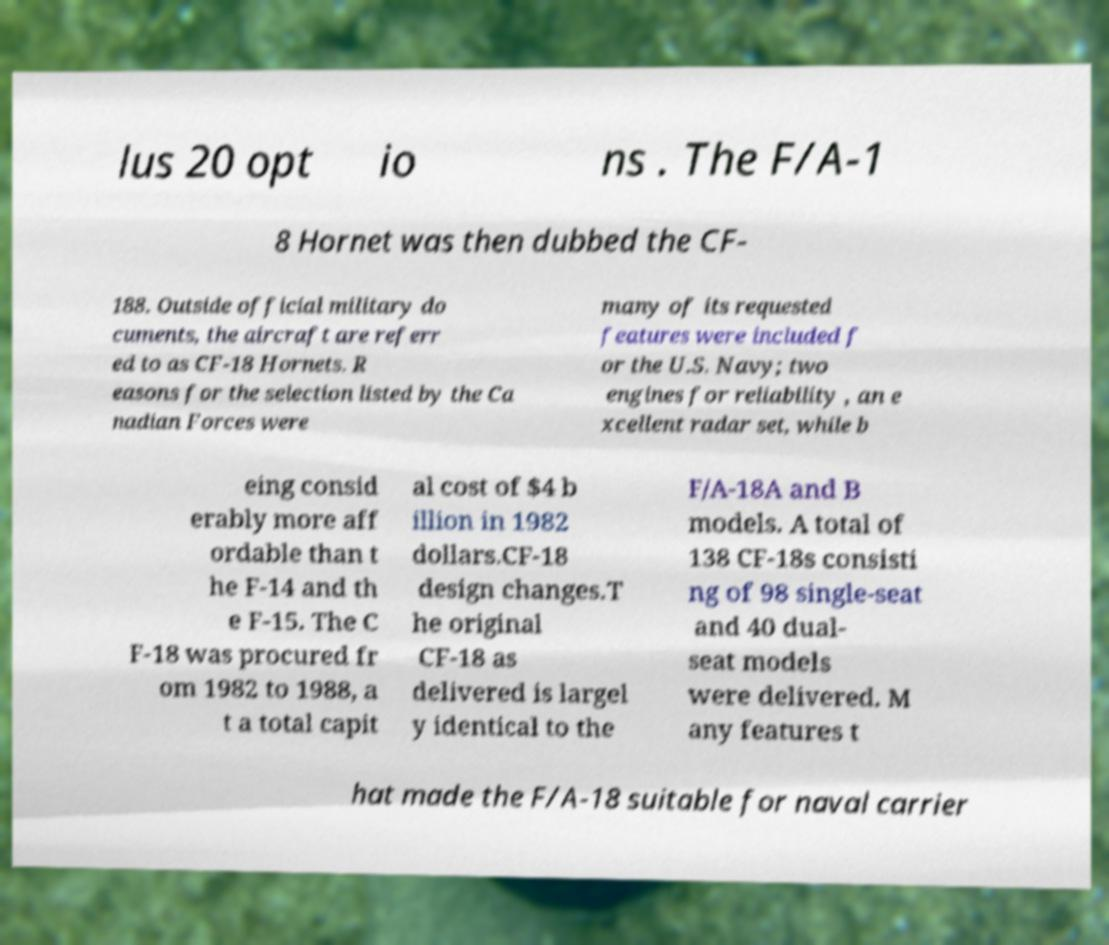What messages or text are displayed in this image? I need them in a readable, typed format. lus 20 opt io ns . The F/A-1 8 Hornet was then dubbed the CF- 188. Outside official military do cuments, the aircraft are referr ed to as CF-18 Hornets. R easons for the selection listed by the Ca nadian Forces were many of its requested features were included f or the U.S. Navy; two engines for reliability , an e xcellent radar set, while b eing consid erably more aff ordable than t he F-14 and th e F-15. The C F-18 was procured fr om 1982 to 1988, a t a total capit al cost of $4 b illion in 1982 dollars.CF-18 design changes.T he original CF-18 as delivered is largel y identical to the F/A-18A and B models. A total of 138 CF-18s consisti ng of 98 single-seat and 40 dual- seat models were delivered. M any features t hat made the F/A-18 suitable for naval carrier 